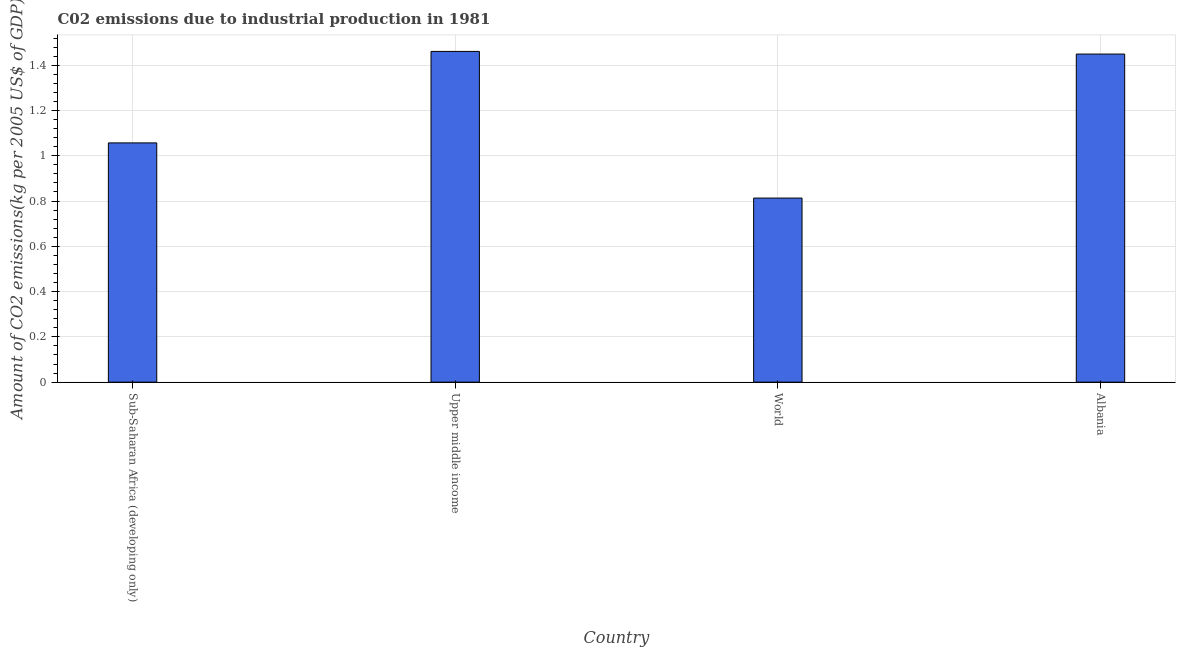Does the graph contain any zero values?
Offer a terse response. No. What is the title of the graph?
Your answer should be compact. C02 emissions due to industrial production in 1981. What is the label or title of the Y-axis?
Offer a very short reply. Amount of CO2 emissions(kg per 2005 US$ of GDP). What is the amount of co2 emissions in World?
Your response must be concise. 0.81. Across all countries, what is the maximum amount of co2 emissions?
Provide a short and direct response. 1.46. Across all countries, what is the minimum amount of co2 emissions?
Provide a succinct answer. 0.81. In which country was the amount of co2 emissions maximum?
Keep it short and to the point. Upper middle income. What is the sum of the amount of co2 emissions?
Offer a very short reply. 4.78. What is the difference between the amount of co2 emissions in Albania and Upper middle income?
Offer a terse response. -0.01. What is the average amount of co2 emissions per country?
Your response must be concise. 1.2. What is the median amount of co2 emissions?
Give a very brief answer. 1.25. In how many countries, is the amount of co2 emissions greater than 0.04 kg per 2005 US$ of GDP?
Your answer should be very brief. 4. What is the ratio of the amount of co2 emissions in Albania to that in World?
Offer a terse response. 1.78. What is the difference between the highest and the second highest amount of co2 emissions?
Provide a succinct answer. 0.01. What is the difference between the highest and the lowest amount of co2 emissions?
Make the answer very short. 0.65. In how many countries, is the amount of co2 emissions greater than the average amount of co2 emissions taken over all countries?
Provide a short and direct response. 2. Are all the bars in the graph horizontal?
Your answer should be compact. No. What is the difference between two consecutive major ticks on the Y-axis?
Keep it short and to the point. 0.2. What is the Amount of CO2 emissions(kg per 2005 US$ of GDP) of Sub-Saharan Africa (developing only)?
Your answer should be compact. 1.06. What is the Amount of CO2 emissions(kg per 2005 US$ of GDP) of Upper middle income?
Give a very brief answer. 1.46. What is the Amount of CO2 emissions(kg per 2005 US$ of GDP) of World?
Make the answer very short. 0.81. What is the Amount of CO2 emissions(kg per 2005 US$ of GDP) in Albania?
Keep it short and to the point. 1.45. What is the difference between the Amount of CO2 emissions(kg per 2005 US$ of GDP) in Sub-Saharan Africa (developing only) and Upper middle income?
Ensure brevity in your answer.  -0.4. What is the difference between the Amount of CO2 emissions(kg per 2005 US$ of GDP) in Sub-Saharan Africa (developing only) and World?
Offer a very short reply. 0.24. What is the difference between the Amount of CO2 emissions(kg per 2005 US$ of GDP) in Sub-Saharan Africa (developing only) and Albania?
Keep it short and to the point. -0.39. What is the difference between the Amount of CO2 emissions(kg per 2005 US$ of GDP) in Upper middle income and World?
Offer a terse response. 0.65. What is the difference between the Amount of CO2 emissions(kg per 2005 US$ of GDP) in Upper middle income and Albania?
Offer a very short reply. 0.01. What is the difference between the Amount of CO2 emissions(kg per 2005 US$ of GDP) in World and Albania?
Offer a terse response. -0.64. What is the ratio of the Amount of CO2 emissions(kg per 2005 US$ of GDP) in Sub-Saharan Africa (developing only) to that in Upper middle income?
Provide a succinct answer. 0.72. What is the ratio of the Amount of CO2 emissions(kg per 2005 US$ of GDP) in Sub-Saharan Africa (developing only) to that in World?
Your response must be concise. 1.3. What is the ratio of the Amount of CO2 emissions(kg per 2005 US$ of GDP) in Sub-Saharan Africa (developing only) to that in Albania?
Offer a very short reply. 0.73. What is the ratio of the Amount of CO2 emissions(kg per 2005 US$ of GDP) in Upper middle income to that in World?
Give a very brief answer. 1.8. What is the ratio of the Amount of CO2 emissions(kg per 2005 US$ of GDP) in Upper middle income to that in Albania?
Give a very brief answer. 1.01. What is the ratio of the Amount of CO2 emissions(kg per 2005 US$ of GDP) in World to that in Albania?
Your answer should be very brief. 0.56. 